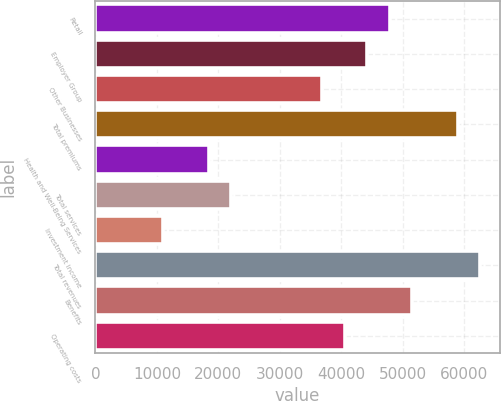Convert chart. <chart><loc_0><loc_0><loc_500><loc_500><bar_chart><fcel>Retail<fcel>Employer Group<fcel>Other Businesses<fcel>Total premiums<fcel>Health and Well-Being Services<fcel>Total services<fcel>Investment income<fcel>Total revenues<fcel>Benefits<fcel>Operating costs<nl><fcel>47879<fcel>44196.7<fcel>36832<fcel>58926.1<fcel>18420.2<fcel>22102.6<fcel>11055.5<fcel>62608.4<fcel>51561.4<fcel>40514.3<nl></chart> 